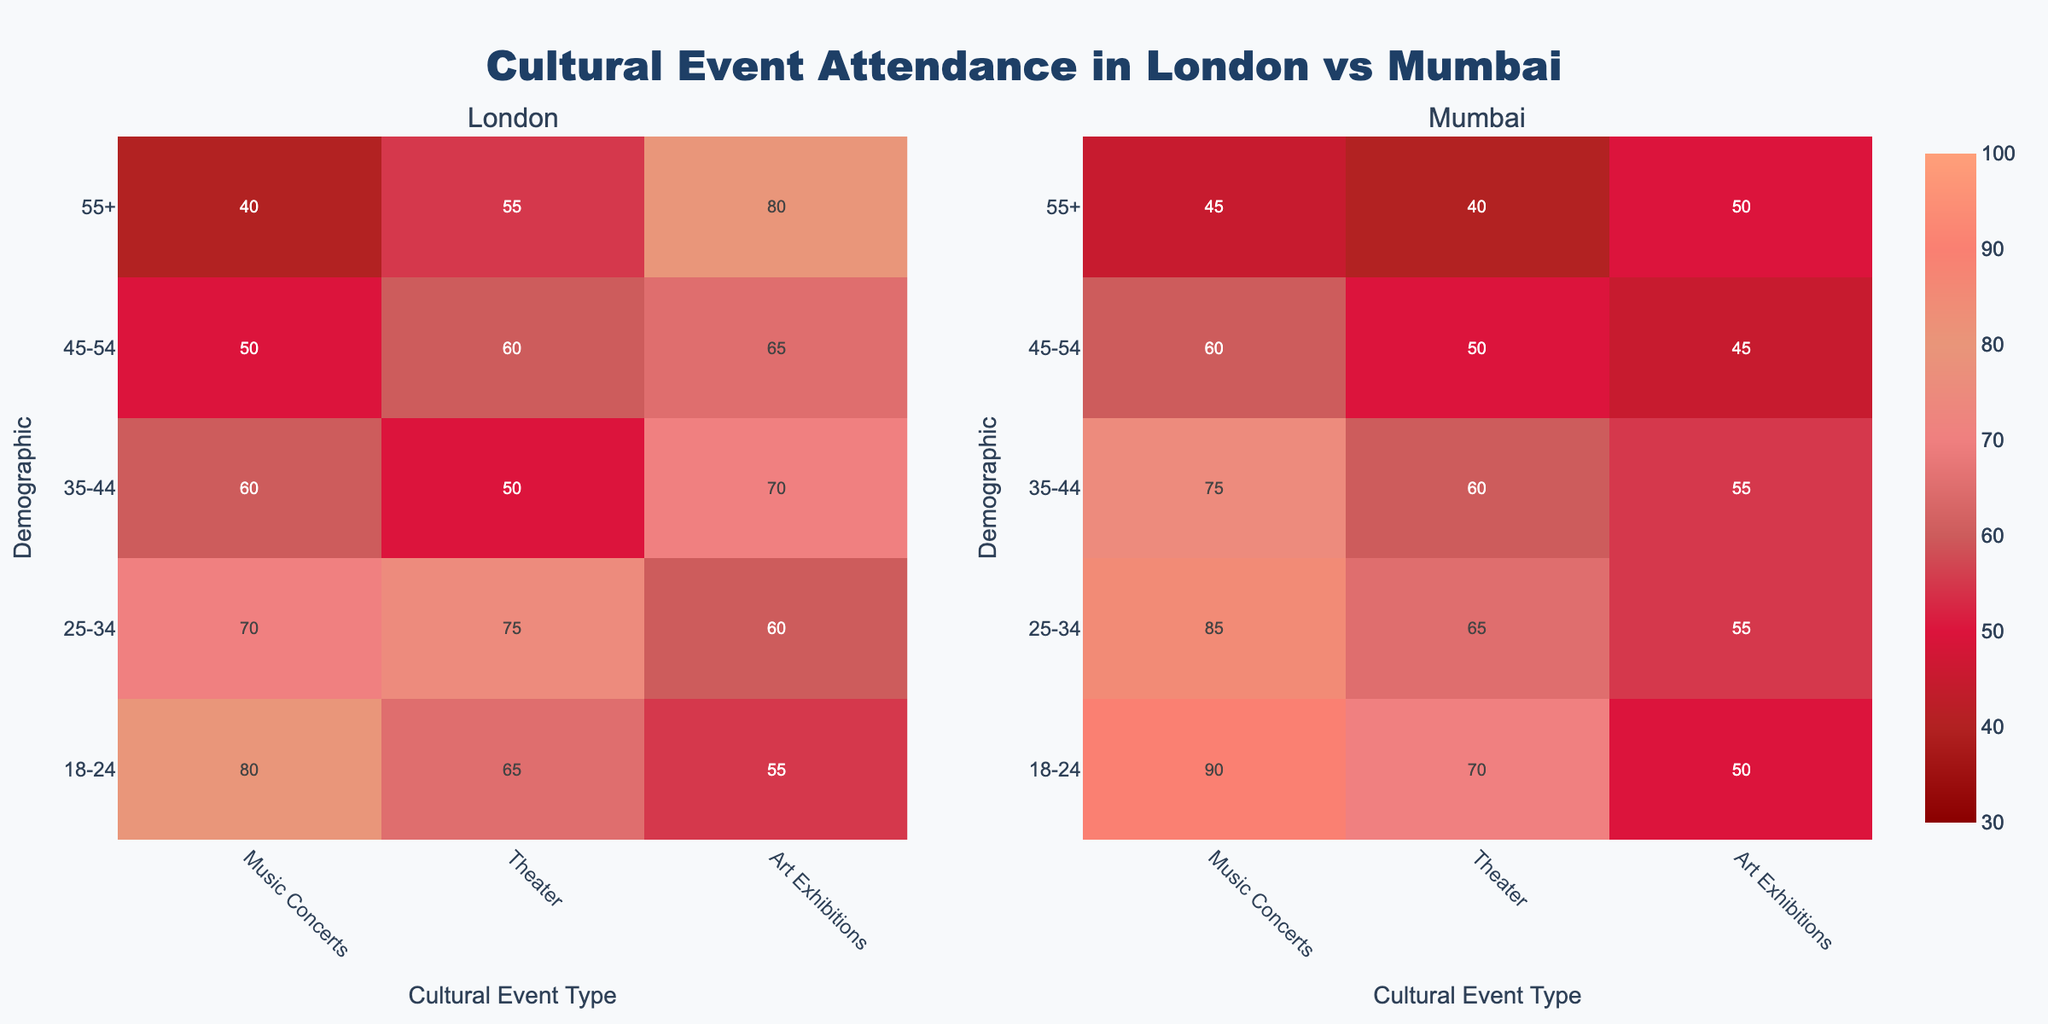What is the title of the heatmap figure? The title of a figure is typically displayed at the top and gives an overview of what the data represents. In this case, the title "Cultural Event Attendance in London vs Mumbai" is shown at the top, indicating the data is about cultural event attendance patterns in two cities.
Answer: Cultural Event Attendance in London vs Mumbai Which demographic has the highest attendance for music concerts in London? To find the demographic with the highest attendance for music concerts in London, look at the color intensity for the column "Music Concerts" under "London." The row with the highest intensity (darkest color) corresponds to the demographic "18-24" with an attendance value of 80.
Answer: 18-24 Which city has a higher attendance for art exhibitions among the 25-34 age demographic? To compare the attendance for art exhibitions among the 25-34 demographic between London and Mumbai, compare the values in the same column and row across both panes. London shows an attendance of 60 and Mumbai shows 55.
Answer: London What is the average attendance of art exhibitions for the age demographic 55+ in both cities? To calculate the average attendance for art exhibitions for the demographic 55+ across both cities, add the attendance values and divide by 2. The values are 80 for London and 50 for Mumbai, so (80 + 50) / 2 = 65.
Answer: 65 Which city shows a greater overall variance in cultural event attendance across all demographics? To assess variance visually, look at the spread and color intensity variation of attendance values in each city. London data shows a greater range from 40 to 80 (more varied color intensities) while Mumbai data shows a smaller range from 40 to 70.
Answer: London Is there a demographic where theater attendance is exactly the same in both cities? To find if there's an exact match in theater attendance between both cities, compare the theater attendance column in identical rows from both panes. The attendance is the same (65) for the 25-34 age demographic.
Answer: 25-34 Which age demographic in Mumbai has the lowest attendance for theater events? To find the demographic with the lowest theater attendance in Mumbai, identify the column labeled "Theater" and check for the lightest color/shadiest area corresponding to the 55+ demographic with an attendance of 40.
Answer: 55+ Compare the attendance of music concerts for the 35-44 demographic between London and Mumbai. Which is higher and by how much? The attendance for music concerts for the 35-44 demographic is 60 in London and 75 in Mumbai. To find the difference, subtract the London attendance from Mumbai attendance: 75 - 60 = 15.
Answer: Mumbai, by 15 What is the total attendance for art exhibitions across all demographics in London? To find the total attendance for Art Exhibitions in London, sum up the attendance values from each demographic for that column: 55 + 60 + 70 + 65 + 80 = 330.
Answer: 330 